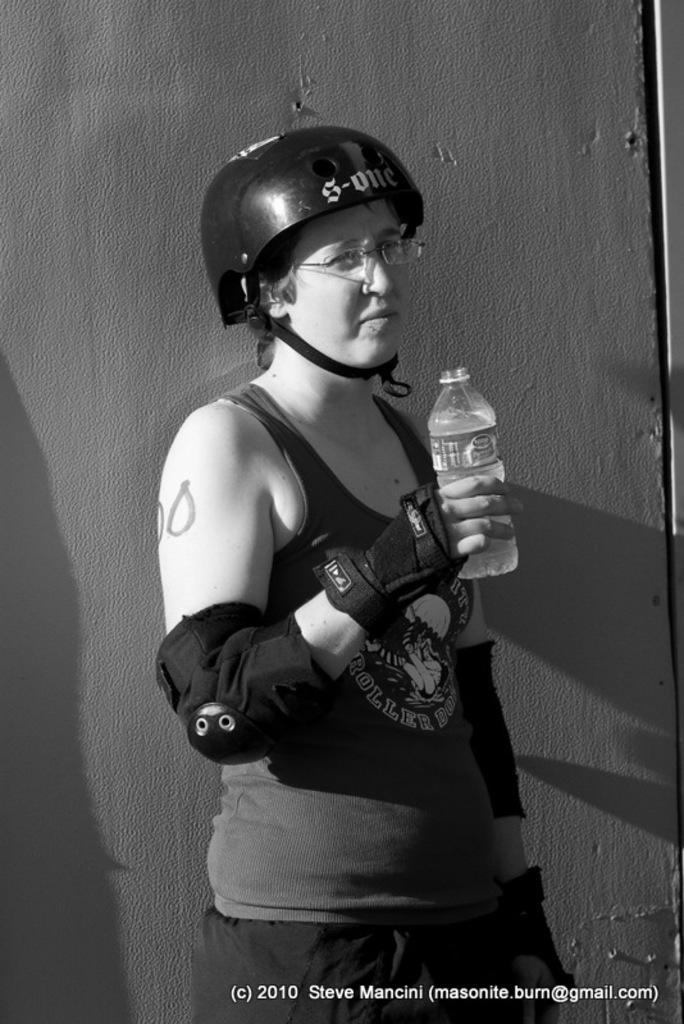Who is the main subject in the picture? There is a girl in the picture. What is the girl wearing on her head? The girl is wearing a helmet. What type of clothing is the girl wearing on her upper body? The girl is wearing a sando top. What is the girl wearing on her hands? The girl is wearing gloves. What is the girl holding in her left hand? The girl is holding a knuckle pad in her hand. What is the girl holding in her right hand? The girl is holding a water bottle in her right hand. Where is the girl standing in the picture? The girl is standing in front of a wall. What activity is the girl participating in the picture? The provided facts do not mention any specific activity that the girl is participating in. --- Facts: 1. There is a car in the image. 2. The car is red. 3. The car has four doors. 4. The car has a sunroof. 5. The car has a spoiler. 6. The car has a license plate. Absurd Topics: parrot, ocean, waves Conversation: What is the main subject in the image? There is a car in the image. What color is the car? The car is red. How many doors does the car have? The car has four doors. Does the car have any special features? Yes, the car has a sunroof and a spoiler. Is there any identification on the car? Yes, the car has a license plate. Reasoning: Let's think step by step in order to produce the conversation. We start by identifying the main subject of the image, which is the car. Next, we describe the car's specific features, such as its color, the number of doors, and the presence of a sunroof and a spoiler. Finally, we mention the presence of a license plate, which serves as an identification for the car. Absurd Question/Answer: Can you see any parrots flying over the car in the image? No, there are no parrots visible in the image. --- Facts: 1. There is a group of people in the image. 2. The people are wearing matching t-shirts. 3. The t-shirts have a logo on the front. 4. The logo is a smiley face. 5. The people are holding hands. 6. The people are standing in a circle. Absurd Topics: elephant, jungle, trunk Conversation: How many people are in the image? There is a group of people in the image. What are the people wearing in the image? The people are wearing matching t-shirts. What is on the front of the t-shirts? The t-shirts 